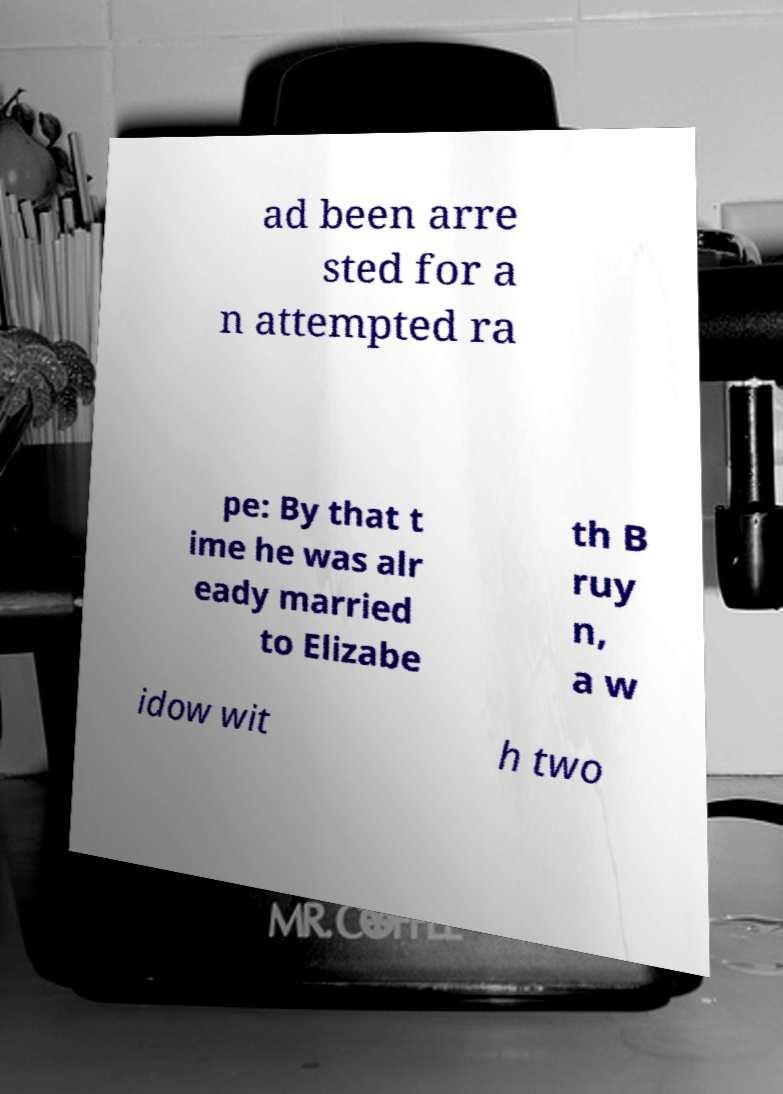What messages or text are displayed in this image? I need them in a readable, typed format. ad been arre sted for a n attempted ra pe: By that t ime he was alr eady married to Elizabe th B ruy n, a w idow wit h two 